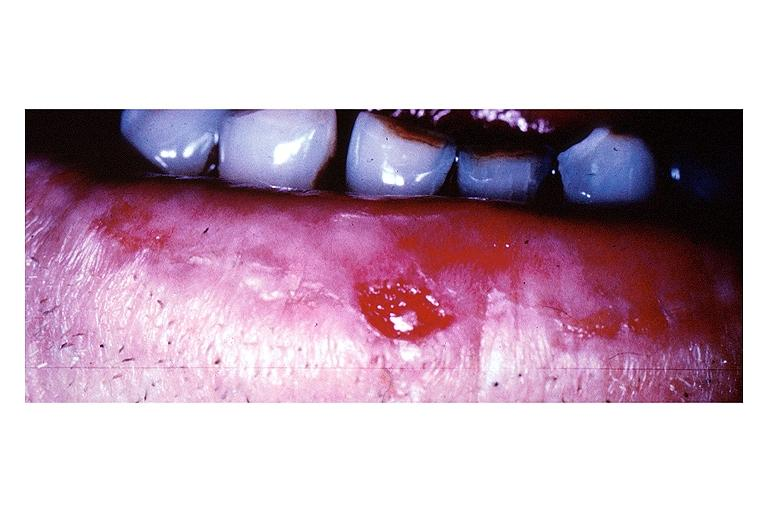what does this image show?
Answer the question using a single word or phrase. Squamous cell carcinoma 